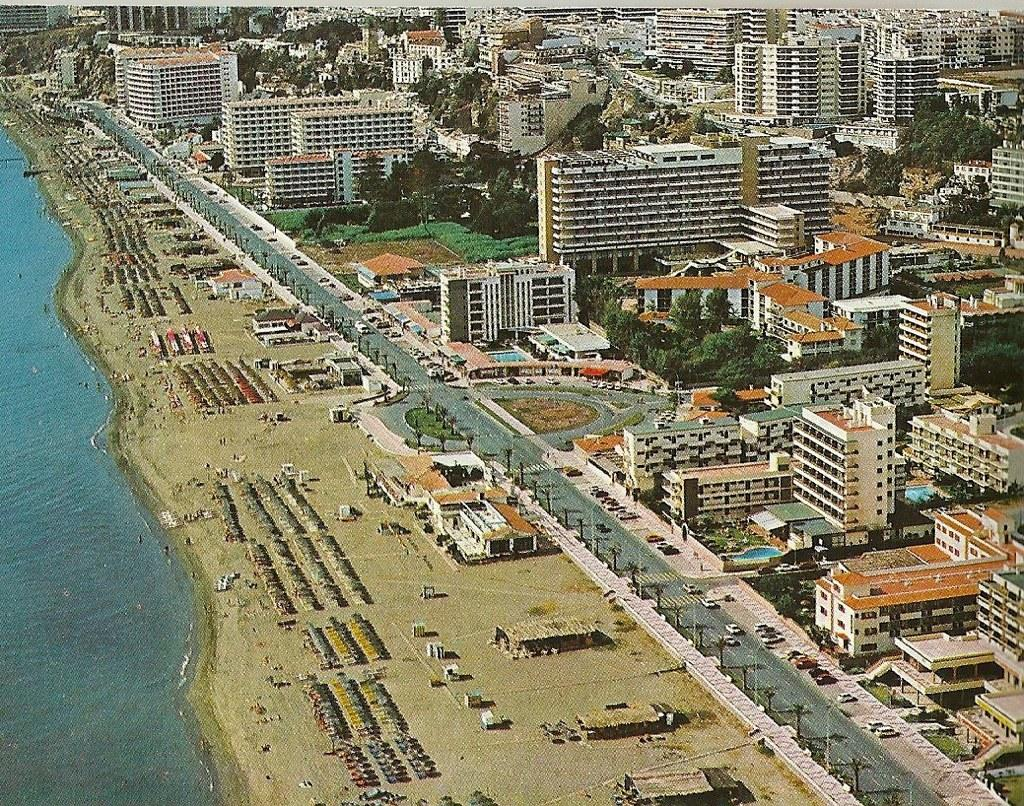What type of structures can be seen in the image? There are buildings in the image. What is the main feature of the landscape in the image? There is a road in the image, and vehicles are moving on it. What natural feature is visible in the image? There is a beach in the image. What type of vegetation is present in the image? There are trees in the image. What body of water is visible in the image? There is an ocean on the left side of the image. What type of grape is being harvested on the beach in the image? There is no grape or grape harvesting depicted in the image; it features buildings, a road, vehicles, a beach, trees, and an ocean. What type of produce is being sold at the beach in the image? There is no produce or produce selling depicted in the image; it features buildings, a road, vehicles, a beach, trees, and an ocean. 